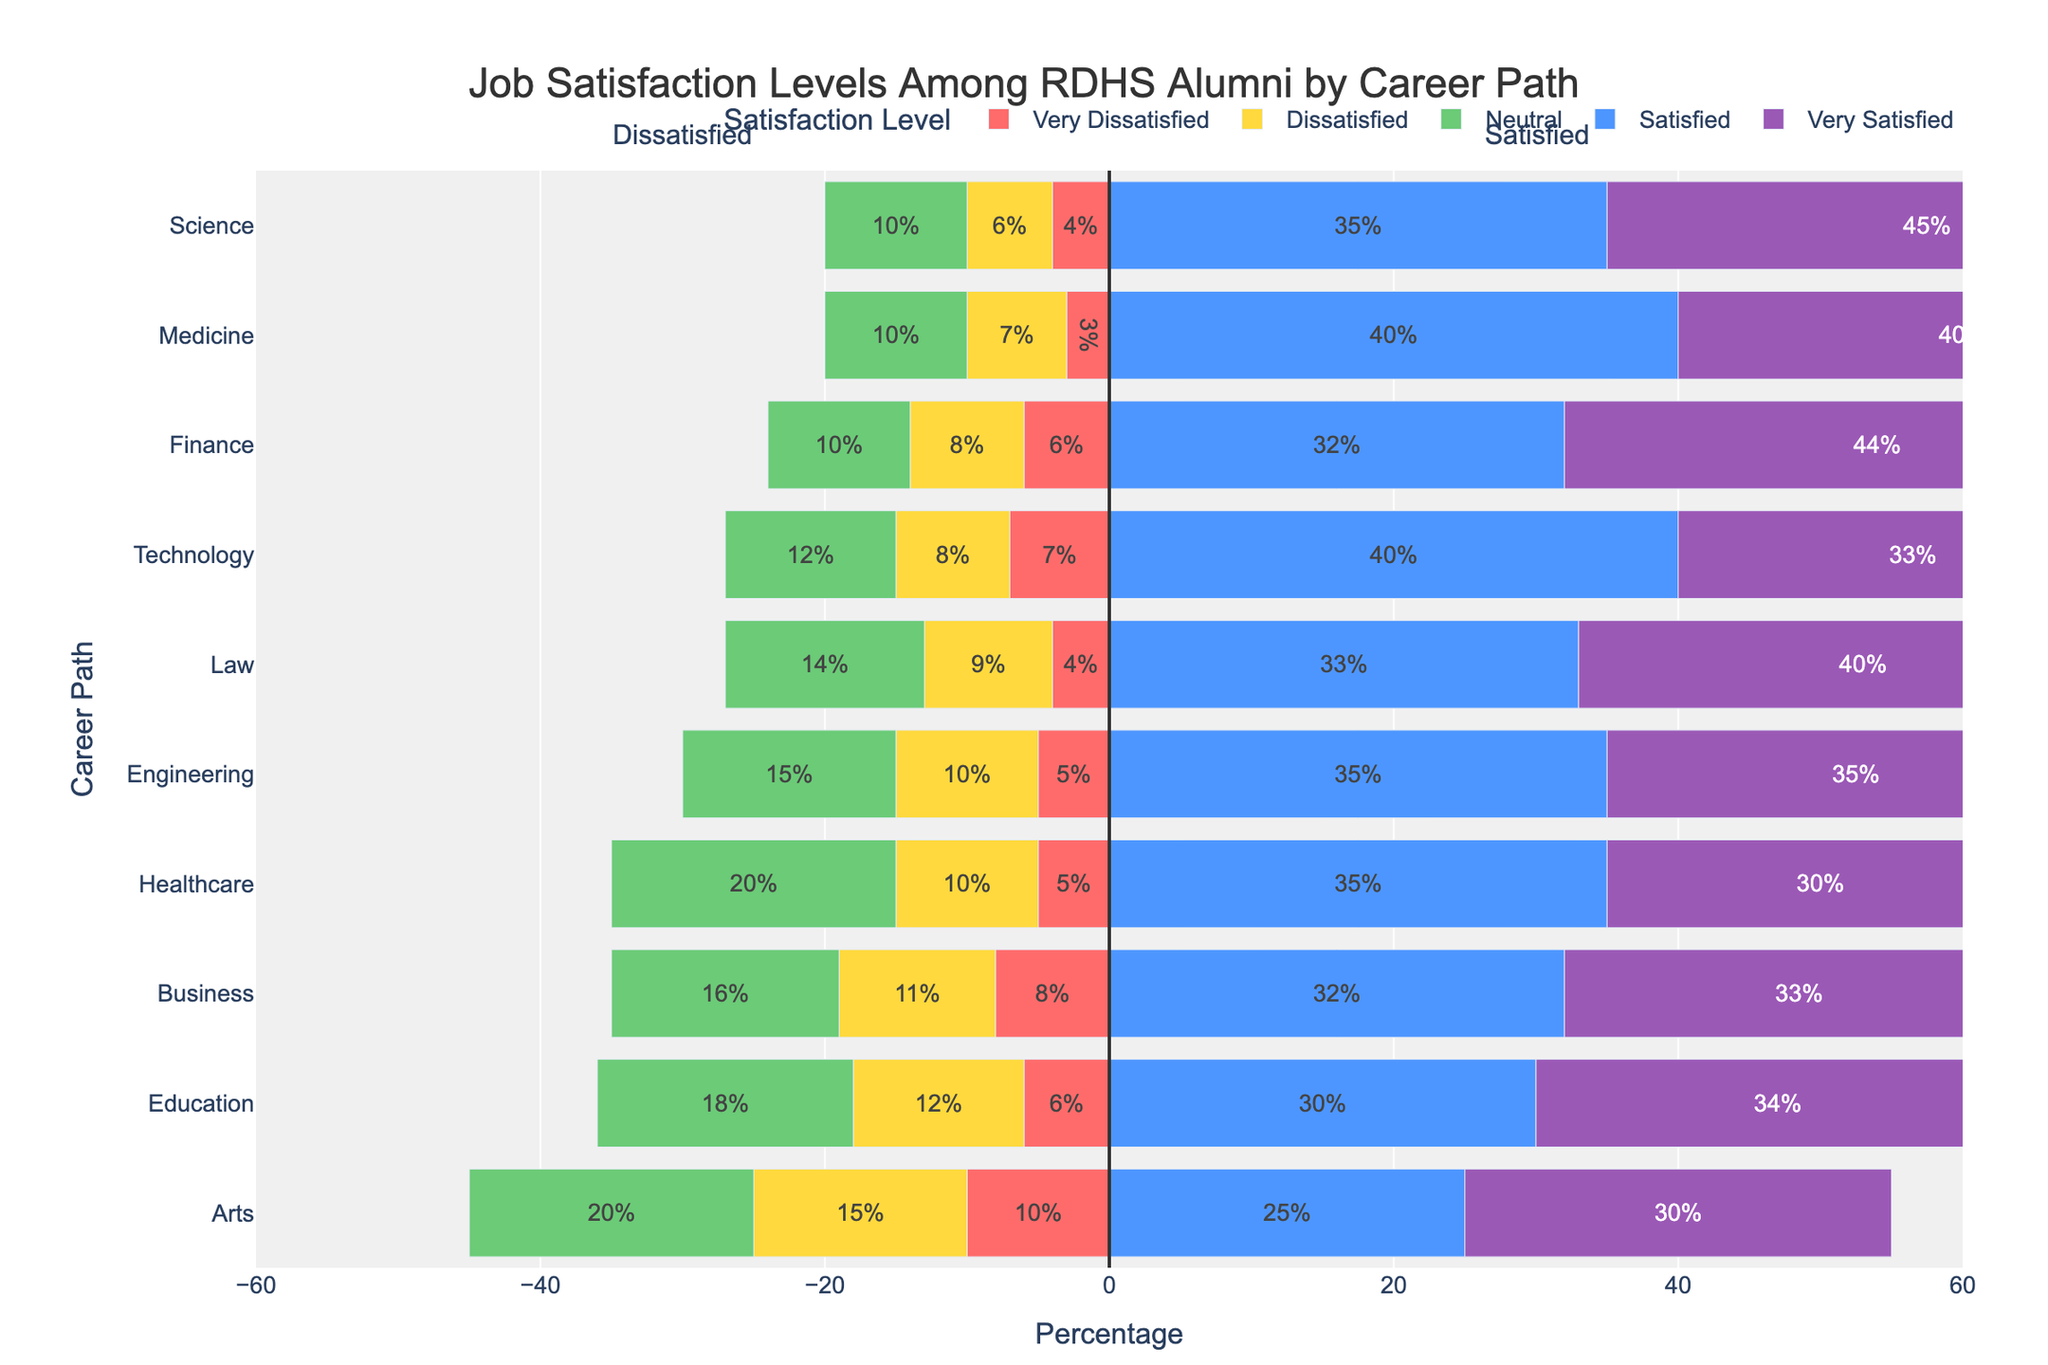What career path has the highest percentage of Very Satisfied alumni? By looking at the bar lengths for the "Very Satisfied" category bars, we see that the longest bar corresponds to the Science career path, indicating it has the highest percentage of Very Satisfied alumni.
Answer: Science Which career path has the lowest percentage of Dissatisfied alumni? By examining the lengths of the "Dissatisfied" bars, we observe that the Healthcare career path has the shortest bar for this category, indicating the lowest percentage of Dissatisfied alumni.
Answer: Healthcare What is the sum of the percentages of Satisfied and Very Satisfied alumni in the Law career path? We need to add the percentage of Satisfied alumni (33%) and Very Satisfied alumni (40%) from the Law career path. By adding 33% + 40%, we get 73%.
Answer: 73% Comparing Medicine and Education, which career path has a higher percentage of Satisfied alumni? By comparing the lengths of the "Satisfied" bars for Medicine and Education, it is clear that the Medicine career path has a longer bar in this category, indicating a higher percentage of Satisfied alumni.
Answer: Medicine What is the difference in the percentage of Neutral alumni between Arts and Business career paths? First, we find the percentages of Neutral alumni in Arts (20%) and Business (16%). Then, we calculate the difference: 20% - 16% = 4%.
Answer: 4% For the Engineering career path, what is the combined percentage of Dissatisfied and Very Dissatisfied alumni? Adding the percentages of Dissatisfied alumni (10%) and Very Dissatisfied alumni (5%) from the Engineering career path, we get 10% + 5% = 15%.
Answer: 15% Which career path has the highest combined percentage of Dissatisfied and Very Dissatisfied alumni? By inspecting the combined lengths of the bars for Dissatisfied and Very Dissatisfied categories for each career path, we observe that Arts has the longest combined bar, indicating the highest combined percentage.
Answer: Arts How many career paths have more than 70% of alumni who are either Satisfied or Very Satisfied? We need to check each career path for the sum of Satisfied and Very Satisfied percentages. If the sum is more than 70%, we count it. Medicine, Law, Science, and Finance meet this criterion. So, there are 4 career paths.
Answer: 4 Which career path has the shortest bar for Very Dissatisfied alumni? By visually examining the length of the "Very Dissatisfied" bars in the chart, we find that Medicine has the shortest bar in this category.
Answer: Medicine Is the percentage of Neutral alumni higher in Education compared to Technology? By comparing the heights of the "Neutral" bars for Education (18%) and Technology (12%), we can see that Education has a higher percentage.
Answer: Yes 